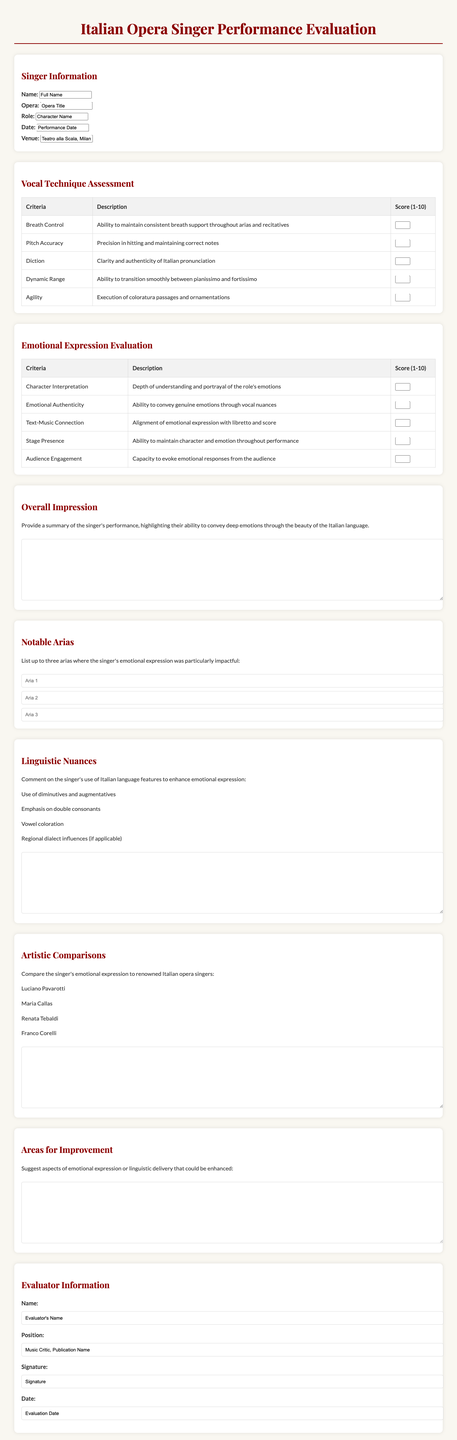what is the title of the performance evaluation form? The title of the form is provided at the top of the document, indicating its purpose.
Answer: Italian Opera Singer Performance Evaluation who is the singer evaluated in this document? The singer's name is listed in the singer information section.
Answer: Full Name what is the date of the performance? The performance date is specified in the singer information section.
Answer: Performance Date how many criteria are there for vocal technique assessment? The number of criteria can be found in the vocal technique assessment section of the document.
Answer: 5 which character name is associated with the singer? The document includes the role played by the singer in the opera section.
Answer: Character Name what aspect of emotional expression is assessed for audience engagement? The specific criterion focused on audience engagement can be found in the emotional expression evaluation section.
Answer: Audience Engagement what is the word limit for the overall impression description? The word limit for this section is mentioned directly in the overall impression description.
Answer: 250 name one of the notable arias listed in the document. The document allows for up to three entries under notable arias, and one can be found there.
Answer: Aria 1 who are the renowned Italian opera singers used for artistic comparisons? The document lists several examples for artistic comparison in the respective section.
Answer: Luciano Pavarotti, Maria Callas, Renata Tebaldi, Franco Corelli what is the main purpose of this evaluation form? The purpose of the evaluation form can be summarized from the overall impression section.
Answer: To assess vocal technique and emotional expression 